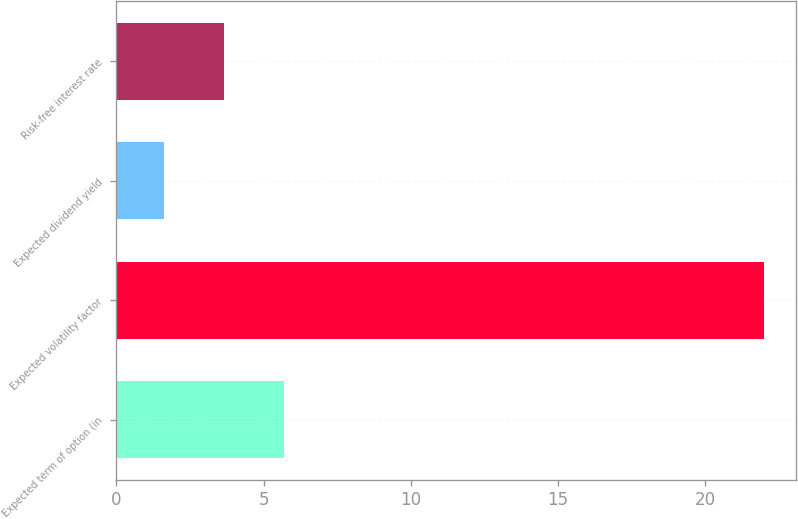Convert chart. <chart><loc_0><loc_0><loc_500><loc_500><bar_chart><fcel>Expected term of option (in<fcel>Expected volatility factor<fcel>Expected dividend yield<fcel>Risk-free interest rate<nl><fcel>5.71<fcel>22.01<fcel>1.63<fcel>3.67<nl></chart> 